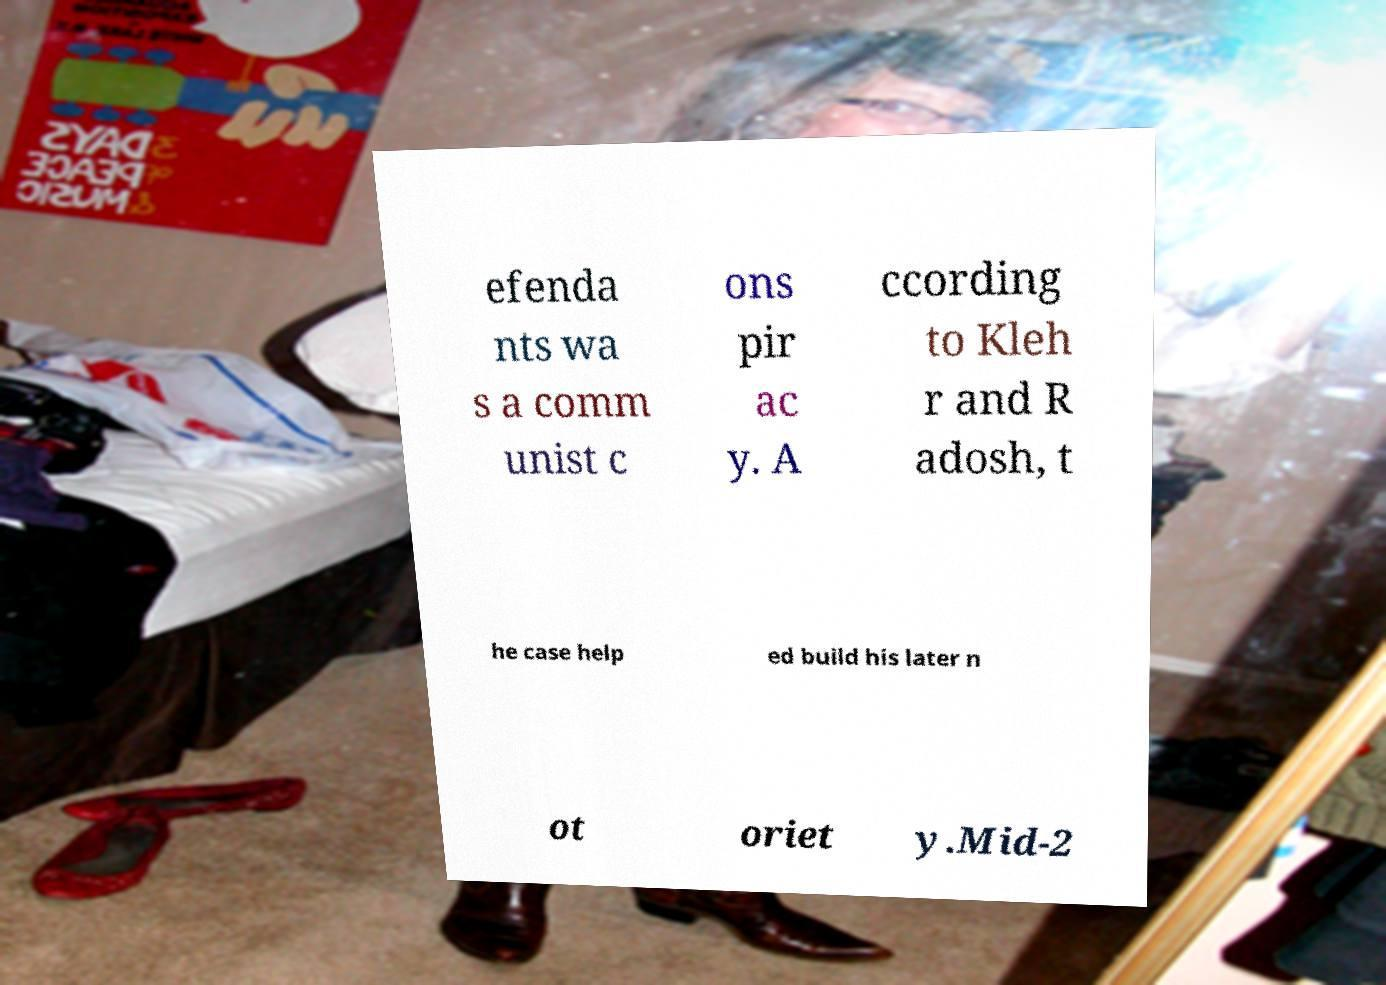Can you accurately transcribe the text from the provided image for me? efenda nts wa s a comm unist c ons pir ac y. A ccording to Kleh r and R adosh, t he case help ed build his later n ot oriet y.Mid-2 